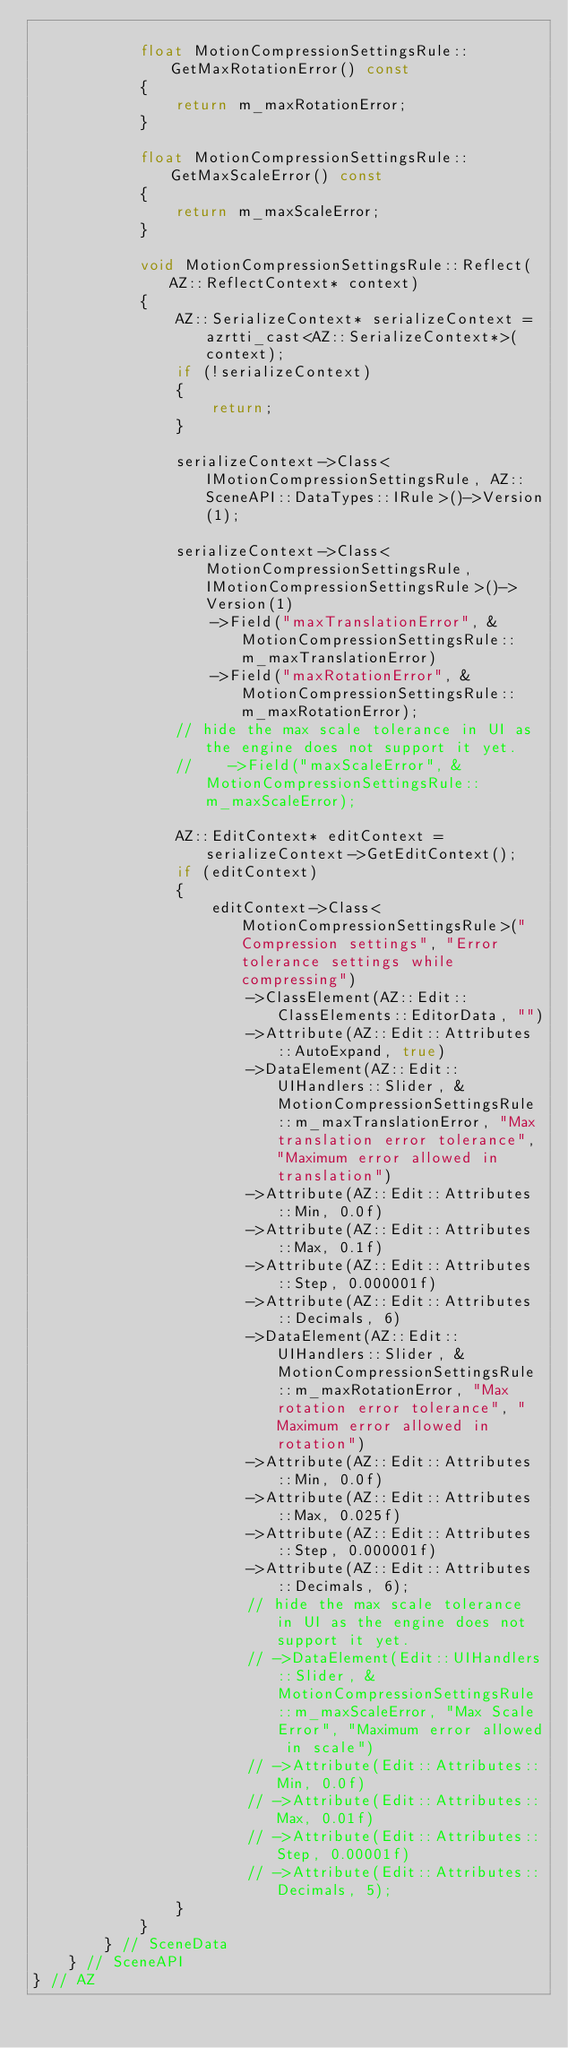Convert code to text. <code><loc_0><loc_0><loc_500><loc_500><_C++_>            
            float MotionCompressionSettingsRule::GetMaxRotationError() const
            {
                return m_maxRotationError;
            }
            
            float MotionCompressionSettingsRule::GetMaxScaleError() const
            {
                return m_maxScaleError;
            }

            void MotionCompressionSettingsRule::Reflect(AZ::ReflectContext* context)
            {
                AZ::SerializeContext* serializeContext = azrtti_cast<AZ::SerializeContext*>(context);
                if (!serializeContext)
                {
                    return;
                }
                
                serializeContext->Class<IMotionCompressionSettingsRule, AZ::SceneAPI::DataTypes::IRule>()->Version(1);

                serializeContext->Class<MotionCompressionSettingsRule, IMotionCompressionSettingsRule>()->Version(1)
                    ->Field("maxTranslationError", &MotionCompressionSettingsRule::m_maxTranslationError)
                    ->Field("maxRotationError", &MotionCompressionSettingsRule::m_maxRotationError);
                // hide the max scale tolerance in UI as the engine does not support it yet.
                //    ->Field("maxScaleError", &MotionCompressionSettingsRule::m_maxScaleError);

                AZ::EditContext* editContext = serializeContext->GetEditContext();
                if (editContext)
                {
                    editContext->Class<MotionCompressionSettingsRule>("Compression settings", "Error tolerance settings while compressing")
                        ->ClassElement(AZ::Edit::ClassElements::EditorData, "")
                        ->Attribute(AZ::Edit::Attributes::AutoExpand, true)
                        ->DataElement(AZ::Edit::UIHandlers::Slider, &MotionCompressionSettingsRule::m_maxTranslationError, "Max translation error tolerance", "Maximum error allowed in translation")
                        ->Attribute(AZ::Edit::Attributes::Min, 0.0f)
                        ->Attribute(AZ::Edit::Attributes::Max, 0.1f)
                        ->Attribute(AZ::Edit::Attributes::Step, 0.000001f)
                        ->Attribute(AZ::Edit::Attributes::Decimals, 6)
                        ->DataElement(AZ::Edit::UIHandlers::Slider, &MotionCompressionSettingsRule::m_maxRotationError, "Max rotation error tolerance", "Maximum error allowed in rotation")
                        ->Attribute(AZ::Edit::Attributes::Min, 0.0f)
                        ->Attribute(AZ::Edit::Attributes::Max, 0.025f)
                        ->Attribute(AZ::Edit::Attributes::Step, 0.000001f)
                        ->Attribute(AZ::Edit::Attributes::Decimals, 6);
                        // hide the max scale tolerance in UI as the engine does not support it yet.
                        // ->DataElement(Edit::UIHandlers::Slider, &MotionCompressionSettingsRule::m_maxScaleError, "Max Scale Error", "Maximum error allowed in scale")
                        // ->Attribute(Edit::Attributes::Min, 0.0f)
                        // ->Attribute(Edit::Attributes::Max, 0.01f)
                        // ->Attribute(Edit::Attributes::Step, 0.00001f)
                        // ->Attribute(Edit::Attributes::Decimals, 5);
                }
            }
        } // SceneData
    } // SceneAPI
} // AZ</code> 